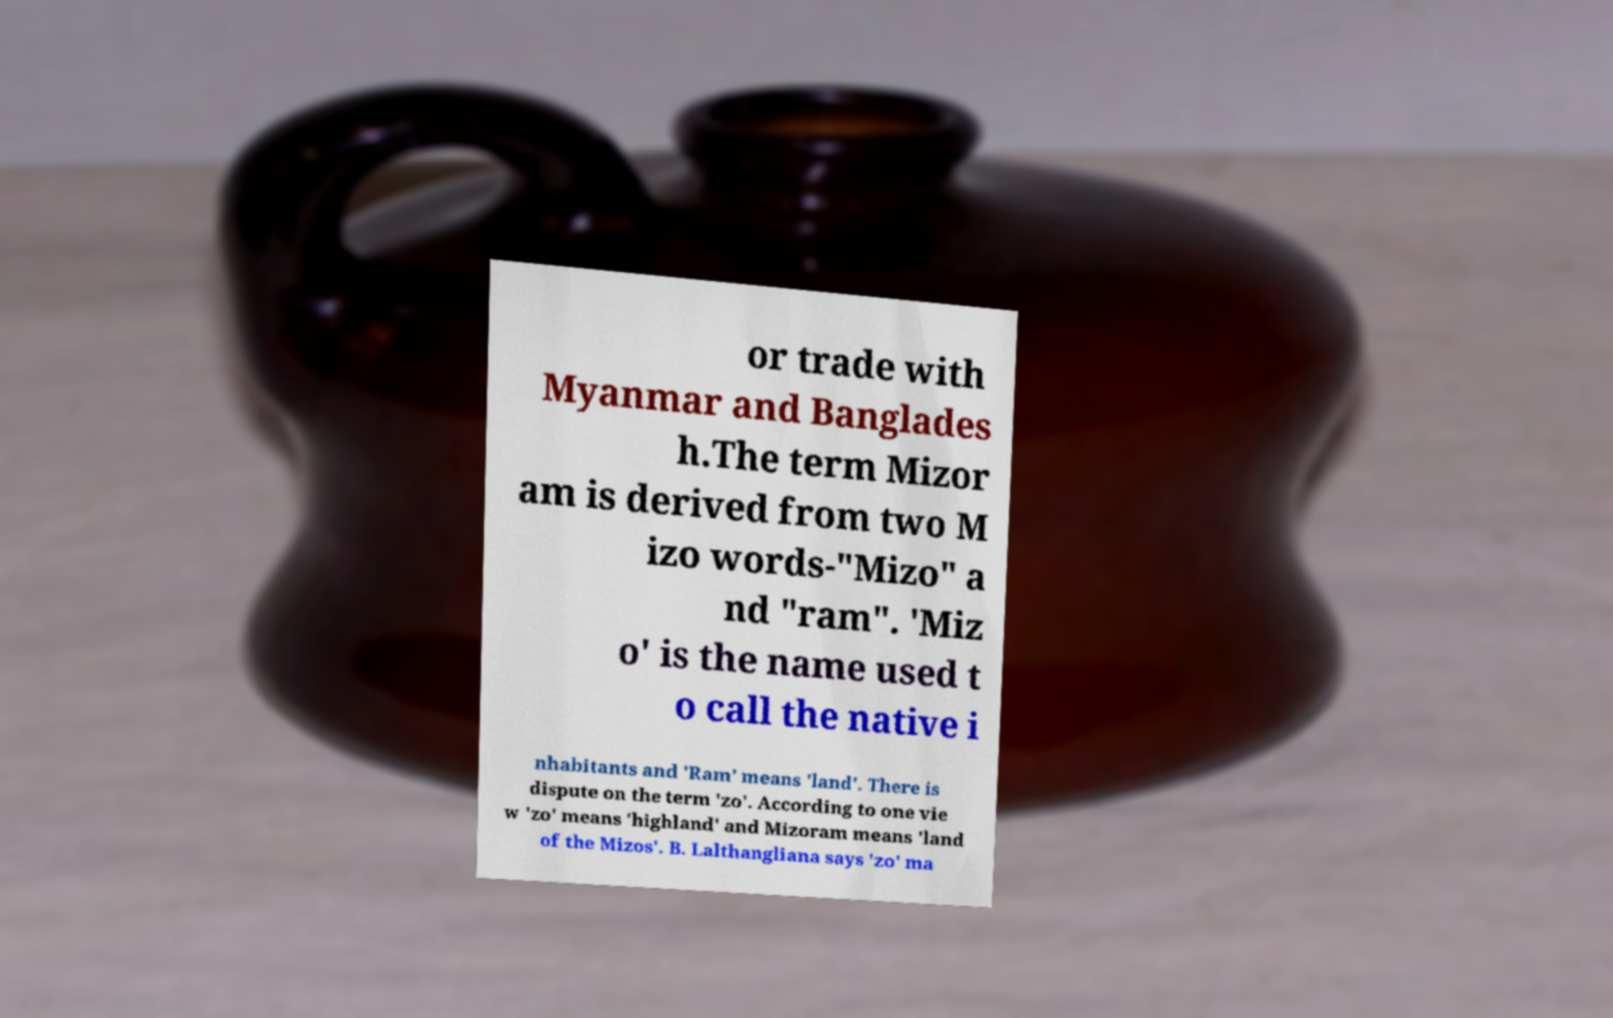There's text embedded in this image that I need extracted. Can you transcribe it verbatim? or trade with Myanmar and Banglades h.The term Mizor am is derived from two M izo words-"Mizo" a nd "ram". 'Miz o' is the name used t o call the native i nhabitants and 'Ram' means 'land'. There is dispute on the term 'zo'. According to one vie w 'zo' means 'highland' and Mizoram means 'land of the Mizos'. B. Lalthangliana says 'zo' ma 